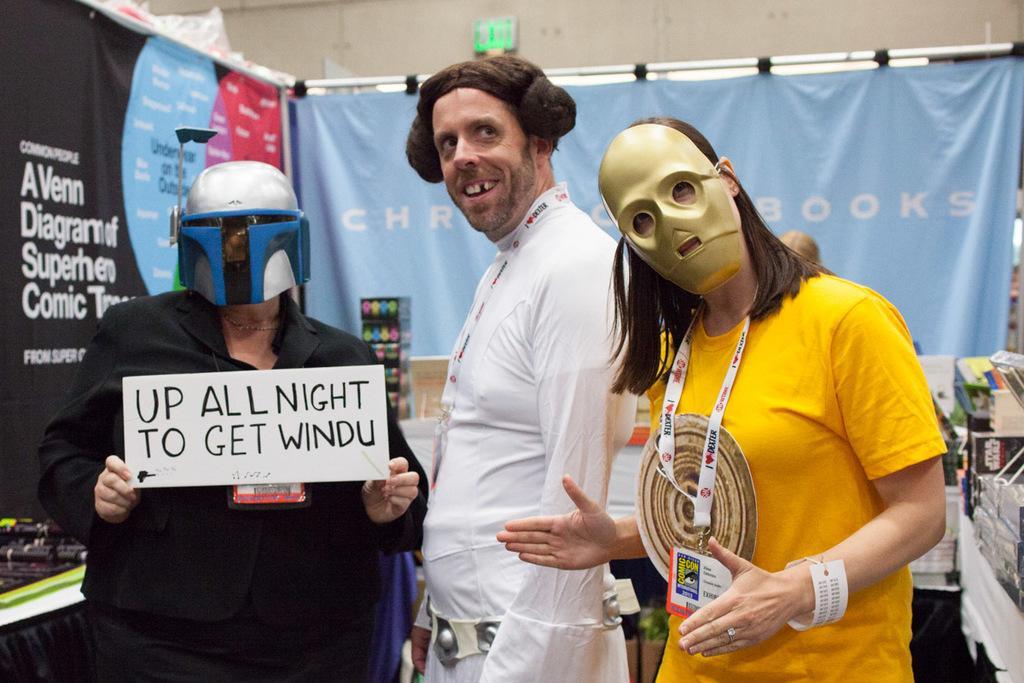Can you describe this image briefly? In this image we can see three persons. One person is wearing a mask and tag. Another person is wearing a helmet and holding a board with some text. In the back there are banners with some text. Also there are few other items. In the background there is a wall. 